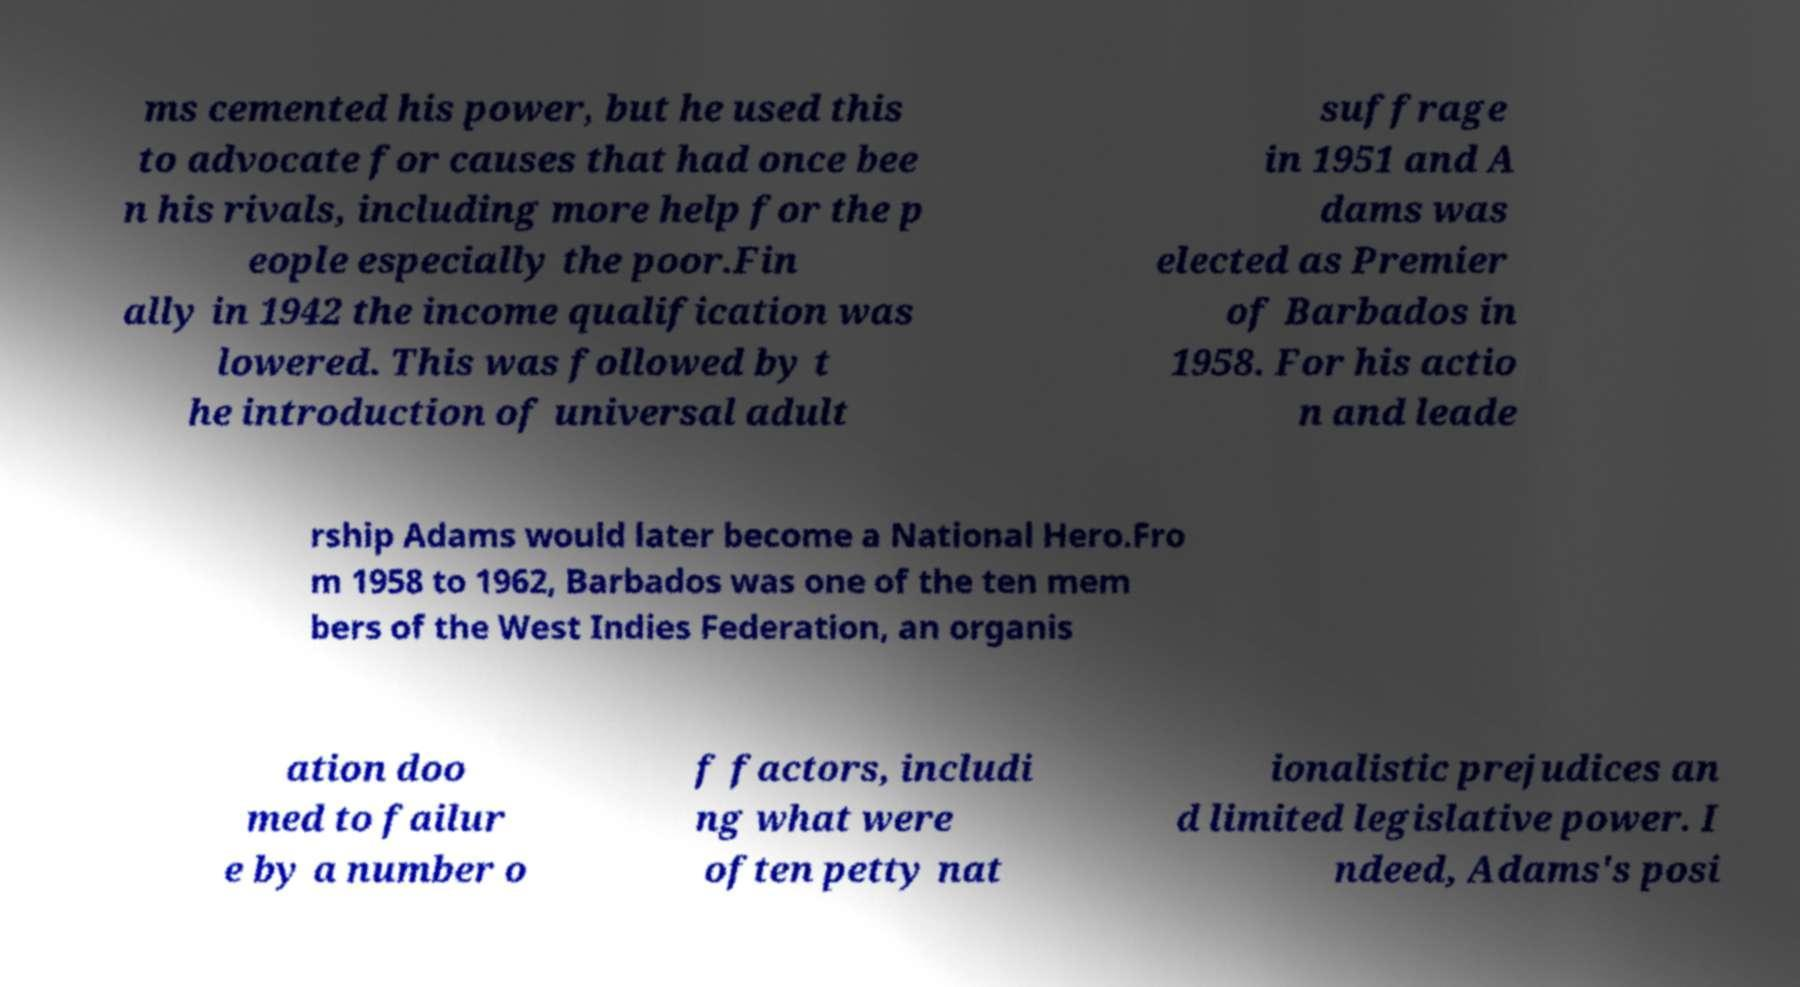Please read and relay the text visible in this image. What does it say? ms cemented his power, but he used this to advocate for causes that had once bee n his rivals, including more help for the p eople especially the poor.Fin ally in 1942 the income qualification was lowered. This was followed by t he introduction of universal adult suffrage in 1951 and A dams was elected as Premier of Barbados in 1958. For his actio n and leade rship Adams would later become a National Hero.Fro m 1958 to 1962, Barbados was one of the ten mem bers of the West Indies Federation, an organis ation doo med to failur e by a number o f factors, includi ng what were often petty nat ionalistic prejudices an d limited legislative power. I ndeed, Adams's posi 